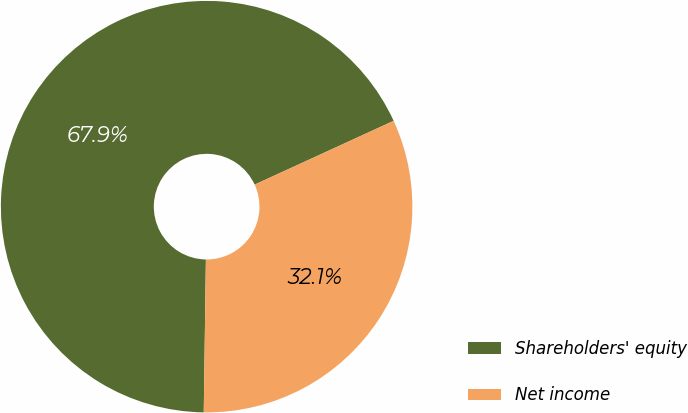Convert chart to OTSL. <chart><loc_0><loc_0><loc_500><loc_500><pie_chart><fcel>Shareholders' equity<fcel>Net income<nl><fcel>67.93%<fcel>32.07%<nl></chart> 